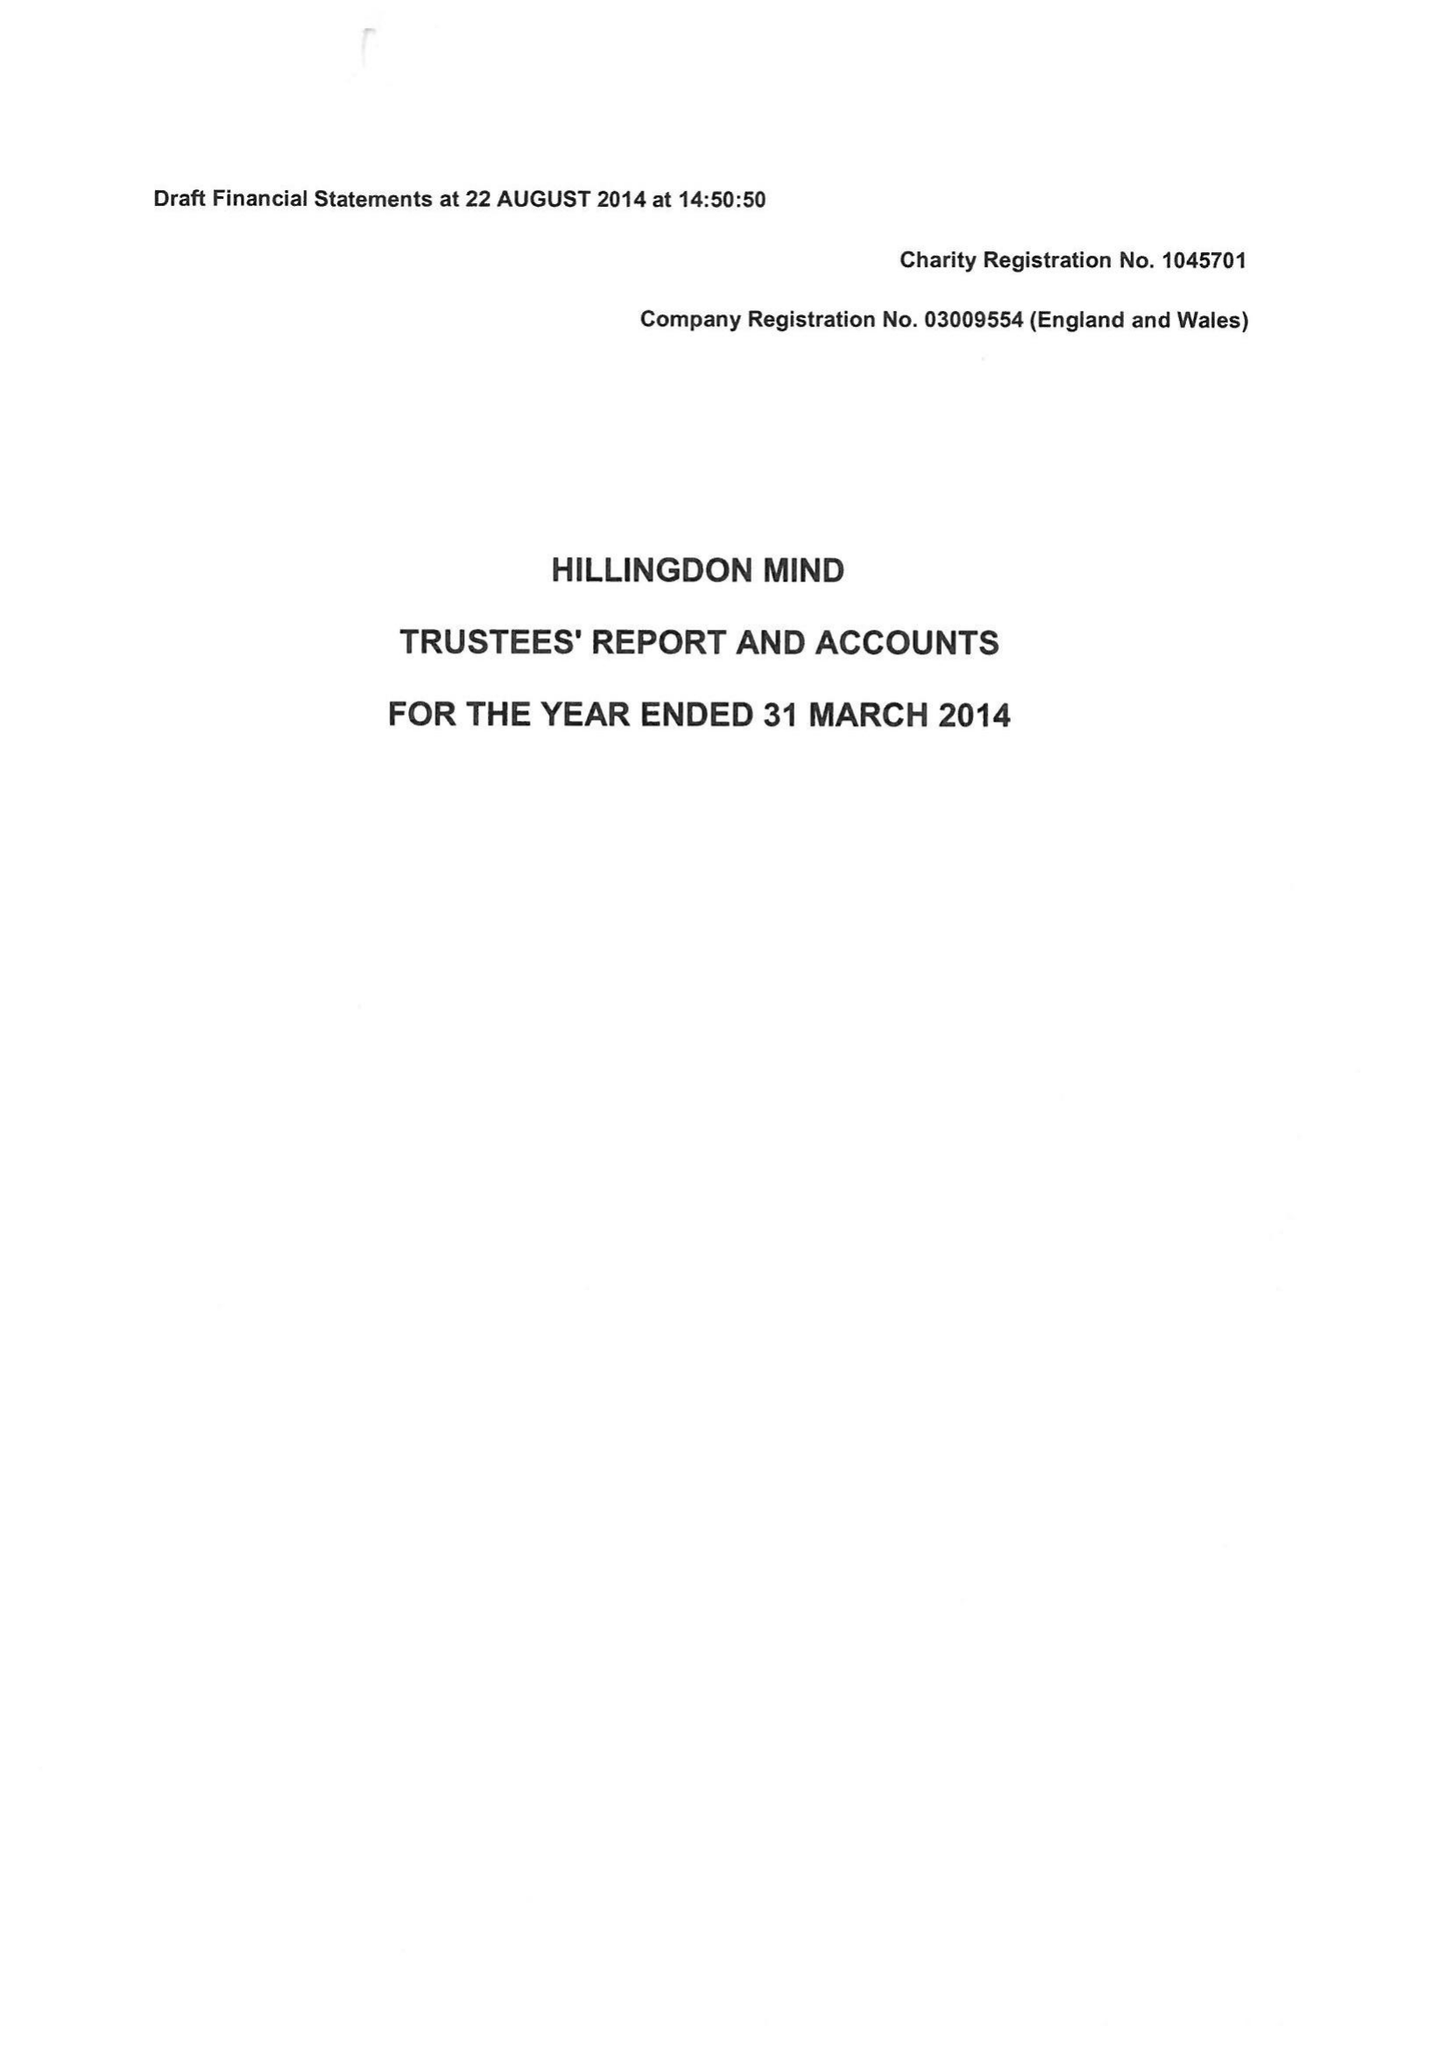What is the value for the charity_number?
Answer the question using a single word or phrase. 1045701 